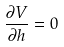Convert formula to latex. <formula><loc_0><loc_0><loc_500><loc_500>\frac { \partial V } { \partial h } = 0</formula> 